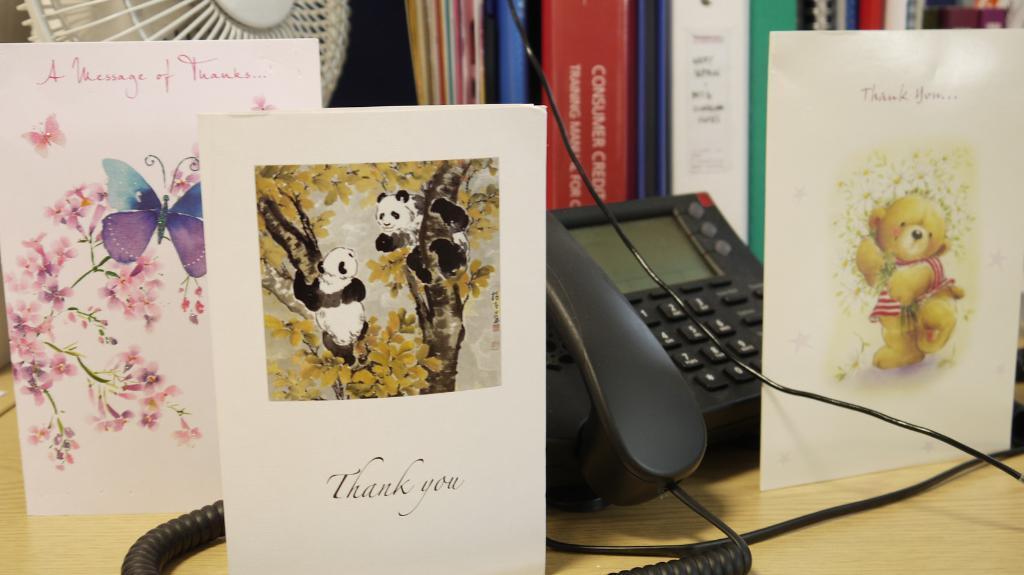In one or two sentences, can you explain what this image depicts? In this image, I can see the greeting cards, telephone, books and a table fan on the table. 